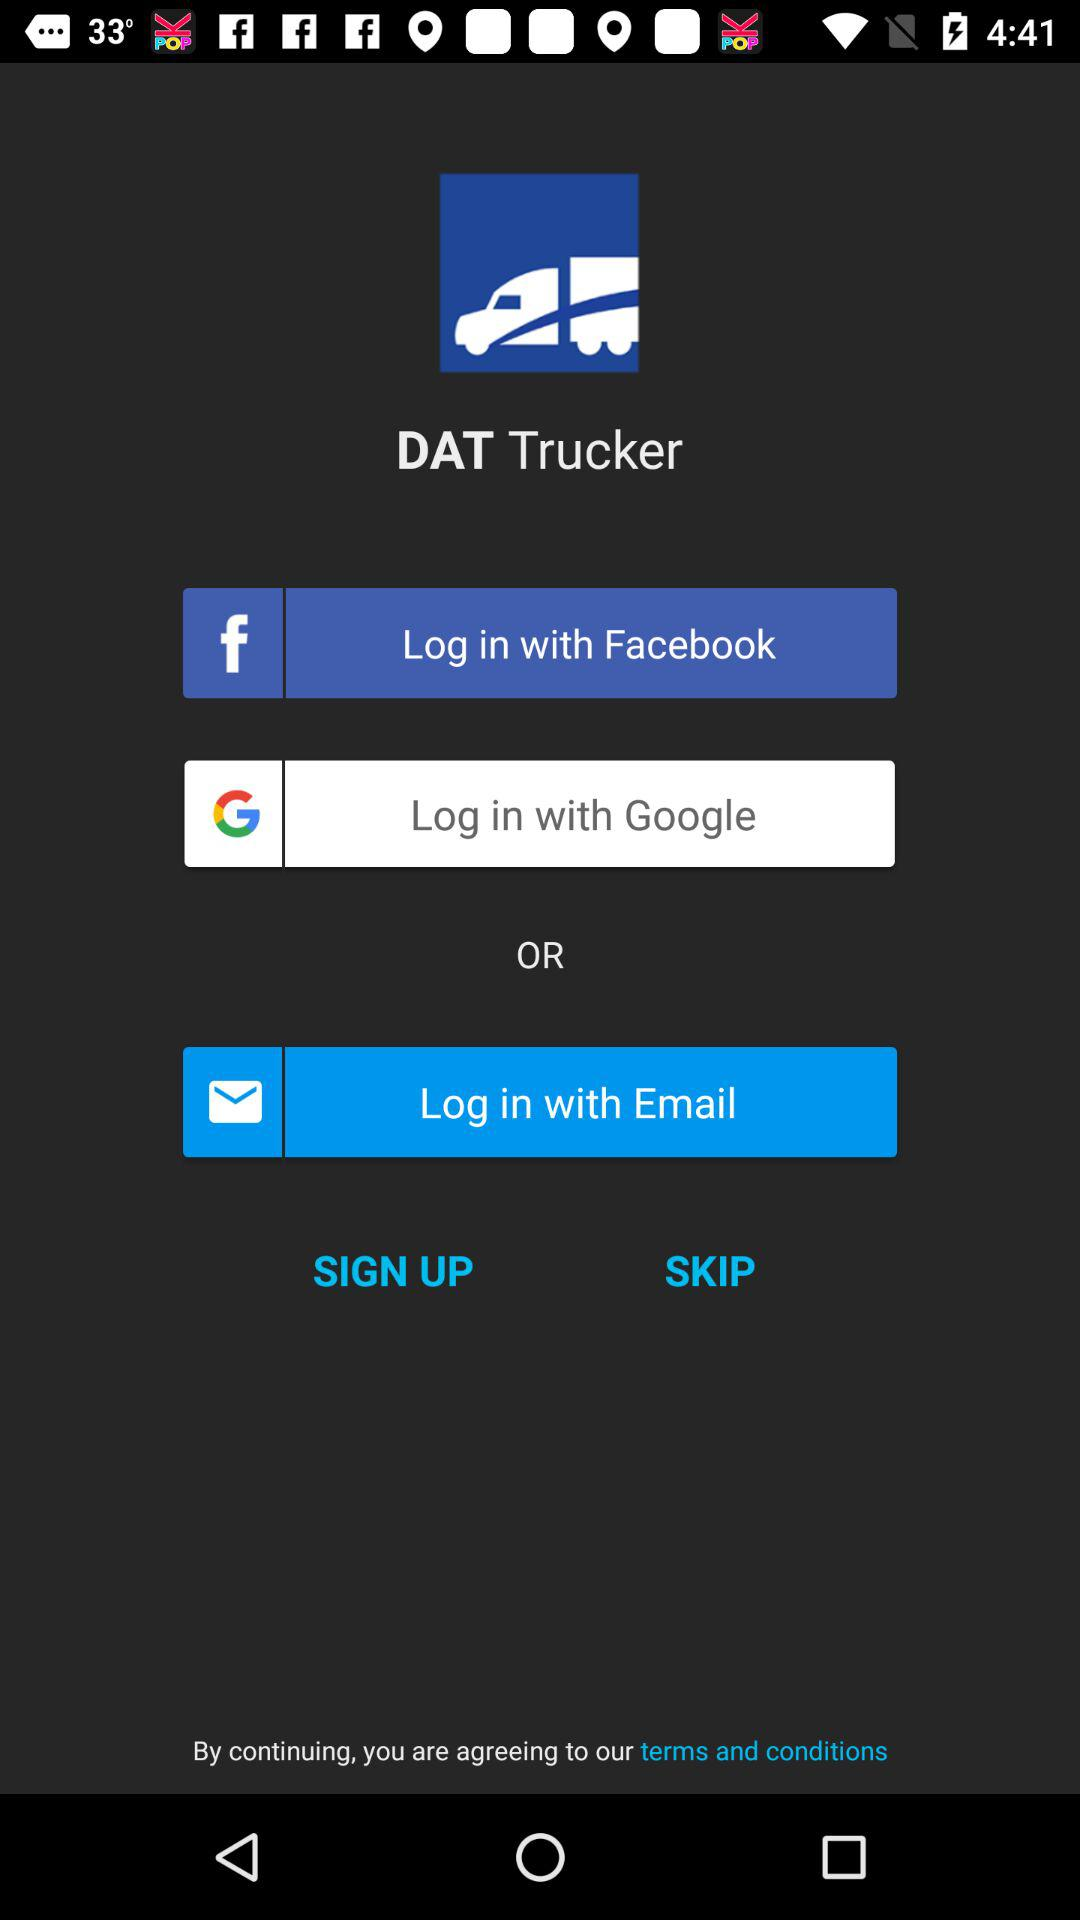What is the name of the application? The name of the application is "DAT Trucker". 